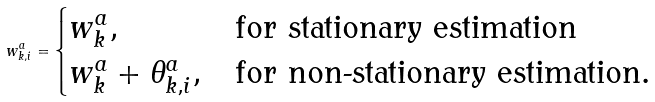<formula> <loc_0><loc_0><loc_500><loc_500>w _ { k , i } ^ { a } = \begin{cases} w _ { k } ^ { a } , & \text {for stationary estimation} \\ w _ { k } ^ { a } + \theta _ { k , i } ^ { a } , & \text {for non-stationary estimation} . \end{cases}</formula> 